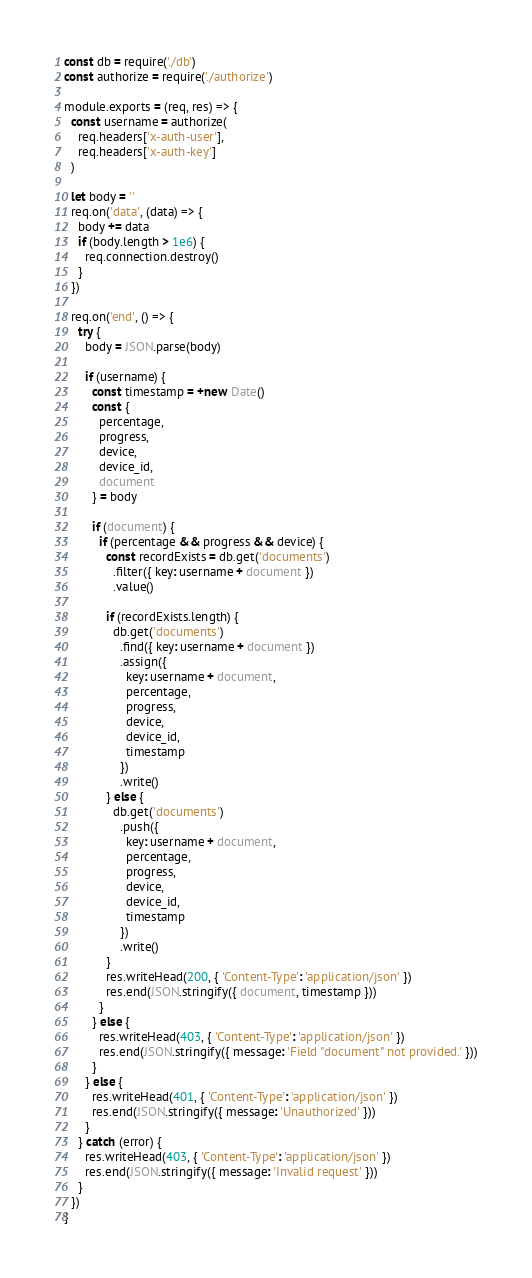Convert code to text. <code><loc_0><loc_0><loc_500><loc_500><_JavaScript_>const db = require('./db')
const authorize = require('./authorize')

module.exports = (req, res) => {
  const username = authorize(
    req.headers['x-auth-user'],
    req.headers['x-auth-key']
  )

  let body = ''
  req.on('data', (data) => {
    body += data
    if (body.length > 1e6) {
      req.connection.destroy()
    }
  })

  req.on('end', () => {
    try {
      body = JSON.parse(body)

      if (username) {
        const timestamp = +new Date()
        const {
          percentage,
          progress,
          device,
          device_id,
          document
        } = body

        if (document) {
          if (percentage && progress && device) {
            const recordExists = db.get('documents')
              .filter({ key: username + document })
              .value()

            if (recordExists.length) {
              db.get('documents')
                .find({ key: username + document })
                .assign({
                  key: username + document,
                  percentage,
                  progress,
                  device,
                  device_id,
                  timestamp
                })
                .write()
            } else {
              db.get('documents')
                .push({
                  key: username + document,
                  percentage,
                  progress,
                  device,
                  device_id,
                  timestamp
                })
                .write()
            }
            res.writeHead(200, { 'Content-Type': 'application/json' })
            res.end(JSON.stringify({ document, timestamp }))
          }
        } else {
          res.writeHead(403, { 'Content-Type': 'application/json' })
          res.end(JSON.stringify({ message: 'Field "document" not provided.' }))
        }
      } else {
        res.writeHead(401, { 'Content-Type': 'application/json' })
        res.end(JSON.stringify({ message: 'Unauthorized' }))
      }
    } catch (error) {
      res.writeHead(403, { 'Content-Type': 'application/json' })
      res.end(JSON.stringify({ message: 'Invalid request' }))
    }
  })
}
</code> 